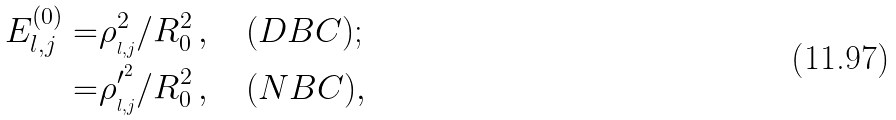<formula> <loc_0><loc_0><loc_500><loc_500>E _ { l , j } ^ { ( 0 ) } = & \rho ^ { 2 } _ { _ { l , j } } / R _ { 0 } ^ { 2 } \, , \quad ( D B C ) ; \\ = & \rho ^ { \prime ^ { 2 } } _ { _ { l , j } } / R _ { 0 } ^ { 2 } \, , \quad ( N B C ) ,</formula> 